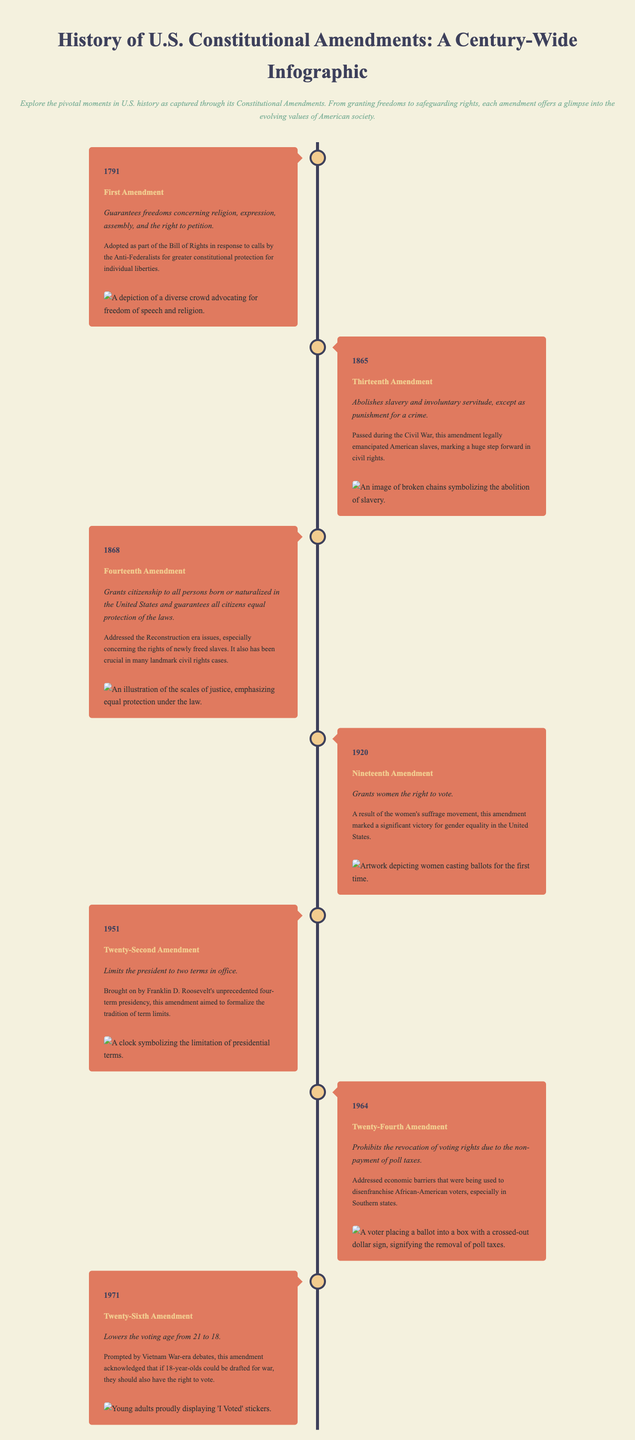What year was the First Amendment adopted? The First Amendment was adopted in 1791, as stated in the timeline.
Answer: 1791 Which amendment abolished slavery? The Thirteenth Amendment, mentioned in the timeline, abolished slavery.
Answer: Thirteenth Amendment What crucial rights does the Fourteenth Amendment guarantee? The Fourteenth Amendment guarantees equal protection of the laws, as described in the summary.
Answer: Equal protection of the laws What significant social movement is associated with the Nineteenth Amendment? The Women's suffrage movement is directly mentioned as the driving force behind the Nineteenth Amendment.
Answer: Women's suffrage movement How many terms does the Twenty-Second Amendment limit the president to? The Twenty-Second Amendment limits the president to two terms in office.
Answer: Two terms What economic barrier was addressed by the Twenty-Fourth Amendment? The Twenty-Fourth Amendment prohibited the revocation of voting rights due to the non-payment of poll taxes, which is detailed in the context.
Answer: Non-payment of poll taxes What was the voting age lowered to with the Twenty-Sixth Amendment? The Twenty-Sixth Amendment lowered the voting age from 21 to 18, as noted in the timeline.
Answer: 18 What event prompted the Twenty-Sixth Amendment? The Vietnam War-era debates prompted the Twenty-Sixth Amendment, according to the document.
Answer: Vietnam War debates 